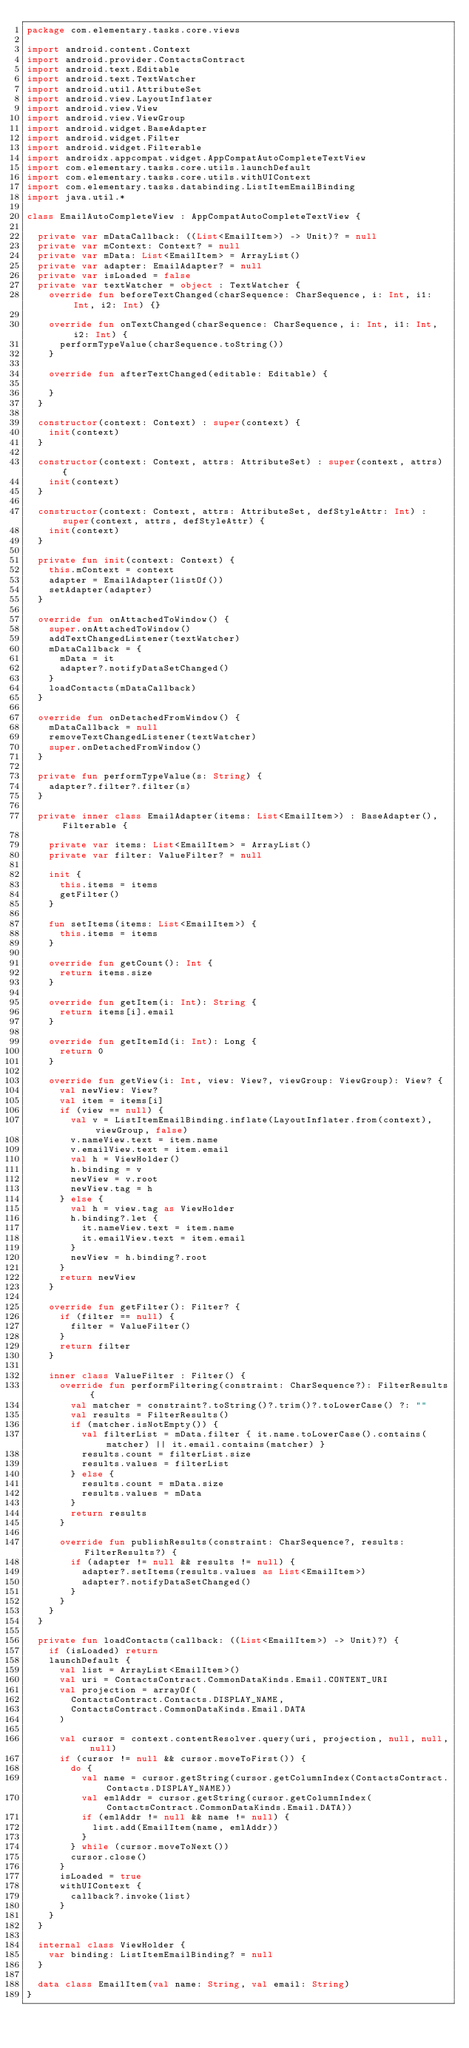Convert code to text. <code><loc_0><loc_0><loc_500><loc_500><_Kotlin_>package com.elementary.tasks.core.views

import android.content.Context
import android.provider.ContactsContract
import android.text.Editable
import android.text.TextWatcher
import android.util.AttributeSet
import android.view.LayoutInflater
import android.view.View
import android.view.ViewGroup
import android.widget.BaseAdapter
import android.widget.Filter
import android.widget.Filterable
import androidx.appcompat.widget.AppCompatAutoCompleteTextView
import com.elementary.tasks.core.utils.launchDefault
import com.elementary.tasks.core.utils.withUIContext
import com.elementary.tasks.databinding.ListItemEmailBinding
import java.util.*

class EmailAutoCompleteView : AppCompatAutoCompleteTextView {

  private var mDataCallback: ((List<EmailItem>) -> Unit)? = null
  private var mContext: Context? = null
  private var mData: List<EmailItem> = ArrayList()
  private var adapter: EmailAdapter? = null
  private var isLoaded = false
  private var textWatcher = object : TextWatcher {
    override fun beforeTextChanged(charSequence: CharSequence, i: Int, i1: Int, i2: Int) {}

    override fun onTextChanged(charSequence: CharSequence, i: Int, i1: Int, i2: Int) {
      performTypeValue(charSequence.toString())
    }

    override fun afterTextChanged(editable: Editable) {

    }
  }

  constructor(context: Context) : super(context) {
    init(context)
  }

  constructor(context: Context, attrs: AttributeSet) : super(context, attrs) {
    init(context)
  }

  constructor(context: Context, attrs: AttributeSet, defStyleAttr: Int) : super(context, attrs, defStyleAttr) {
    init(context)
  }

  private fun init(context: Context) {
    this.mContext = context
    adapter = EmailAdapter(listOf())
    setAdapter(adapter)
  }

  override fun onAttachedToWindow() {
    super.onAttachedToWindow()
    addTextChangedListener(textWatcher)
    mDataCallback = {
      mData = it
      adapter?.notifyDataSetChanged()
    }
    loadContacts(mDataCallback)
  }

  override fun onDetachedFromWindow() {
    mDataCallback = null
    removeTextChangedListener(textWatcher)
    super.onDetachedFromWindow()
  }

  private fun performTypeValue(s: String) {
    adapter?.filter?.filter(s)
  }

  private inner class EmailAdapter(items: List<EmailItem>) : BaseAdapter(), Filterable {

    private var items: List<EmailItem> = ArrayList()
    private var filter: ValueFilter? = null

    init {
      this.items = items
      getFilter()
    }

    fun setItems(items: List<EmailItem>) {
      this.items = items
    }

    override fun getCount(): Int {
      return items.size
    }

    override fun getItem(i: Int): String {
      return items[i].email
    }

    override fun getItemId(i: Int): Long {
      return 0
    }

    override fun getView(i: Int, view: View?, viewGroup: ViewGroup): View? {
      val newView: View?
      val item = items[i]
      if (view == null) {
        val v = ListItemEmailBinding.inflate(LayoutInflater.from(context), viewGroup, false)
        v.nameView.text = item.name
        v.emailView.text = item.email
        val h = ViewHolder()
        h.binding = v
        newView = v.root
        newView.tag = h
      } else {
        val h = view.tag as ViewHolder
        h.binding?.let {
          it.nameView.text = item.name
          it.emailView.text = item.email
        }
        newView = h.binding?.root
      }
      return newView
    }

    override fun getFilter(): Filter? {
      if (filter == null) {
        filter = ValueFilter()
      }
      return filter
    }

    inner class ValueFilter : Filter() {
      override fun performFiltering(constraint: CharSequence?): FilterResults {
        val matcher = constraint?.toString()?.trim()?.toLowerCase() ?: ""
        val results = FilterResults()
        if (matcher.isNotEmpty()) {
          val filterList = mData.filter { it.name.toLowerCase().contains(matcher) || it.email.contains(matcher) }
          results.count = filterList.size
          results.values = filterList
        } else {
          results.count = mData.size
          results.values = mData
        }
        return results
      }

      override fun publishResults(constraint: CharSequence?, results: FilterResults?) {
        if (adapter != null && results != null) {
          adapter?.setItems(results.values as List<EmailItem>)
          adapter?.notifyDataSetChanged()
        }
      }
    }
  }

  private fun loadContacts(callback: ((List<EmailItem>) -> Unit)?) {
    if (isLoaded) return
    launchDefault {
      val list = ArrayList<EmailItem>()
      val uri = ContactsContract.CommonDataKinds.Email.CONTENT_URI
      val projection = arrayOf(
        ContactsContract.Contacts.DISPLAY_NAME,
        ContactsContract.CommonDataKinds.Email.DATA
      )

      val cursor = context.contentResolver.query(uri, projection, null, null, null)
      if (cursor != null && cursor.moveToFirst()) {
        do {
          val name = cursor.getString(cursor.getColumnIndex(ContactsContract.Contacts.DISPLAY_NAME))
          val emlAddr = cursor.getString(cursor.getColumnIndex(ContactsContract.CommonDataKinds.Email.DATA))
          if (emlAddr != null && name != null) {
            list.add(EmailItem(name, emlAddr))
          }
        } while (cursor.moveToNext())
        cursor.close()
      }
      isLoaded = true
      withUIContext {
        callback?.invoke(list)
      }
    }
  }

  internal class ViewHolder {
    var binding: ListItemEmailBinding? = null
  }

  data class EmailItem(val name: String, val email: String)
}
</code> 